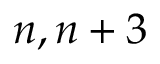Convert formula to latex. <formula><loc_0><loc_0><loc_500><loc_500>n , n + 3</formula> 